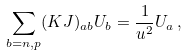<formula> <loc_0><loc_0><loc_500><loc_500>\sum _ { b = n , p } ( K J ) _ { a b } U _ { b } = \frac { 1 } { u ^ { 2 } } U _ { a } \, ,</formula> 